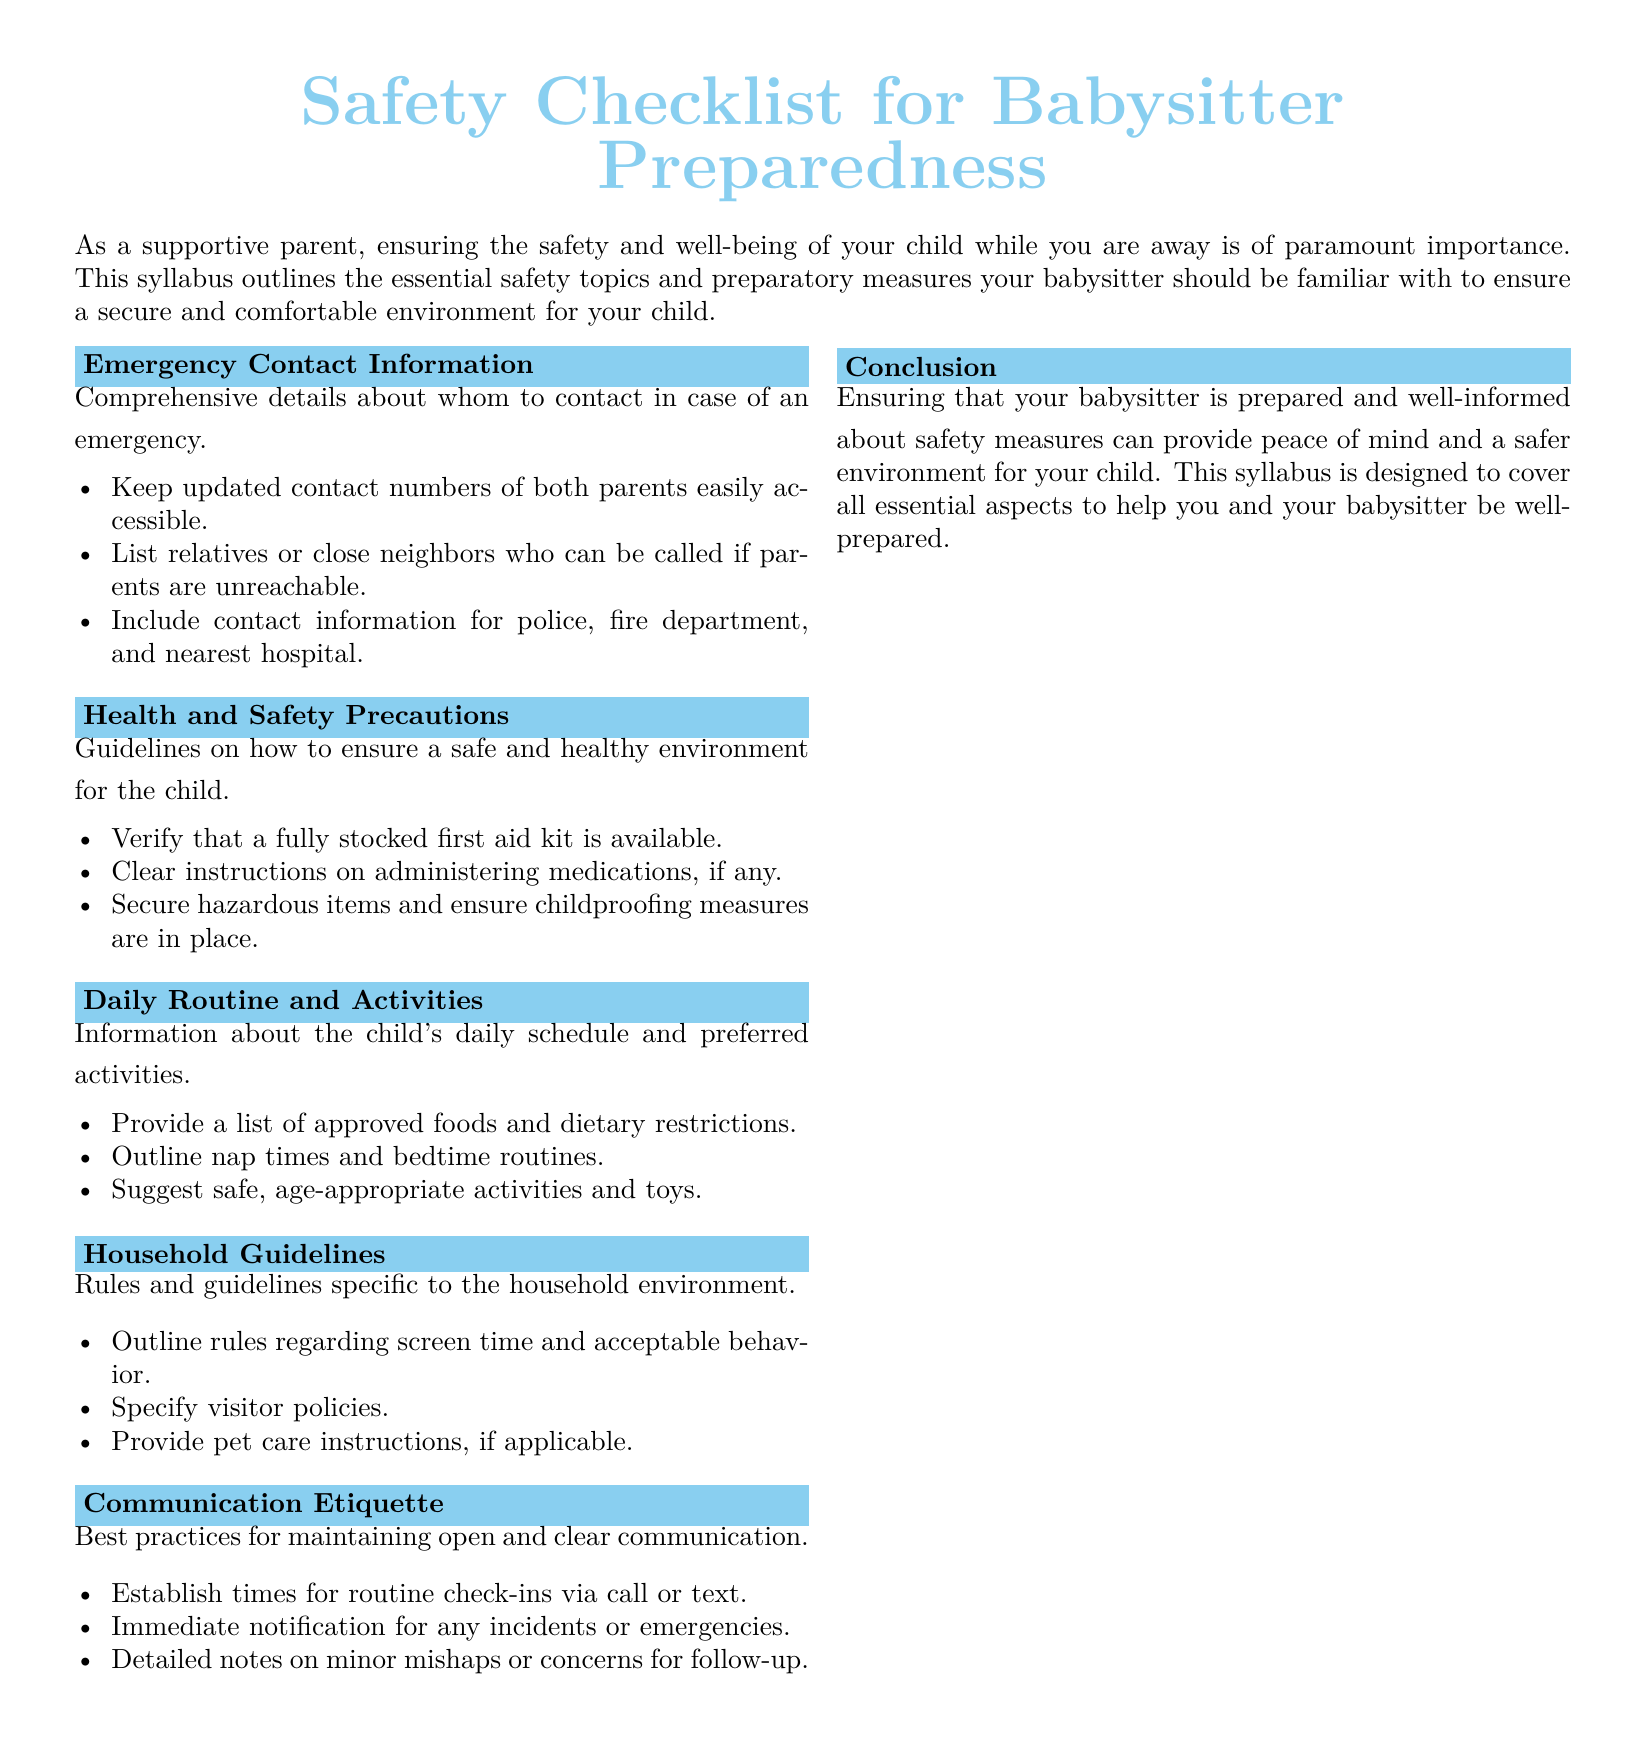What is included in the emergency contact information? The emergency contact information includes updated contact numbers of both parents, relatives or close neighbors, and contact information for police, fire department, and nearest hospital.
Answer: Updated contact numbers What should the babysitter verify regarding health and safety precautions? The babysitter should verify that a fully stocked first aid kit is available.
Answer: Fully stocked first aid kit What should the babysitter outline about the child's daily routine? The babysitter should outline nap times and bedtime routines.
Answer: Nap times What rules are specified in the household guidelines? The household guidelines specify rules regarding screen time and acceptable behavior.
Answer: Screen time rules What is the purpose of the communication etiquette section? The purpose is to maintain open and clear communication between parents and babysitters.
Answer: Open communication What should the babysitter do in case of an incident? The babysitter should immediately notify the parents for any incidents or emergencies.
Answer: Immediately notify parents How many sections are there in the syllabus? The syllabus contains six sections including the conclusion.
Answer: Six sections What color is used for the section titles? The color used for the section titles is baby blue.
Answer: Baby blue What type of document is this? This document is a syllabus outlining safety checklist for babysitters.
Answer: Syllabus 